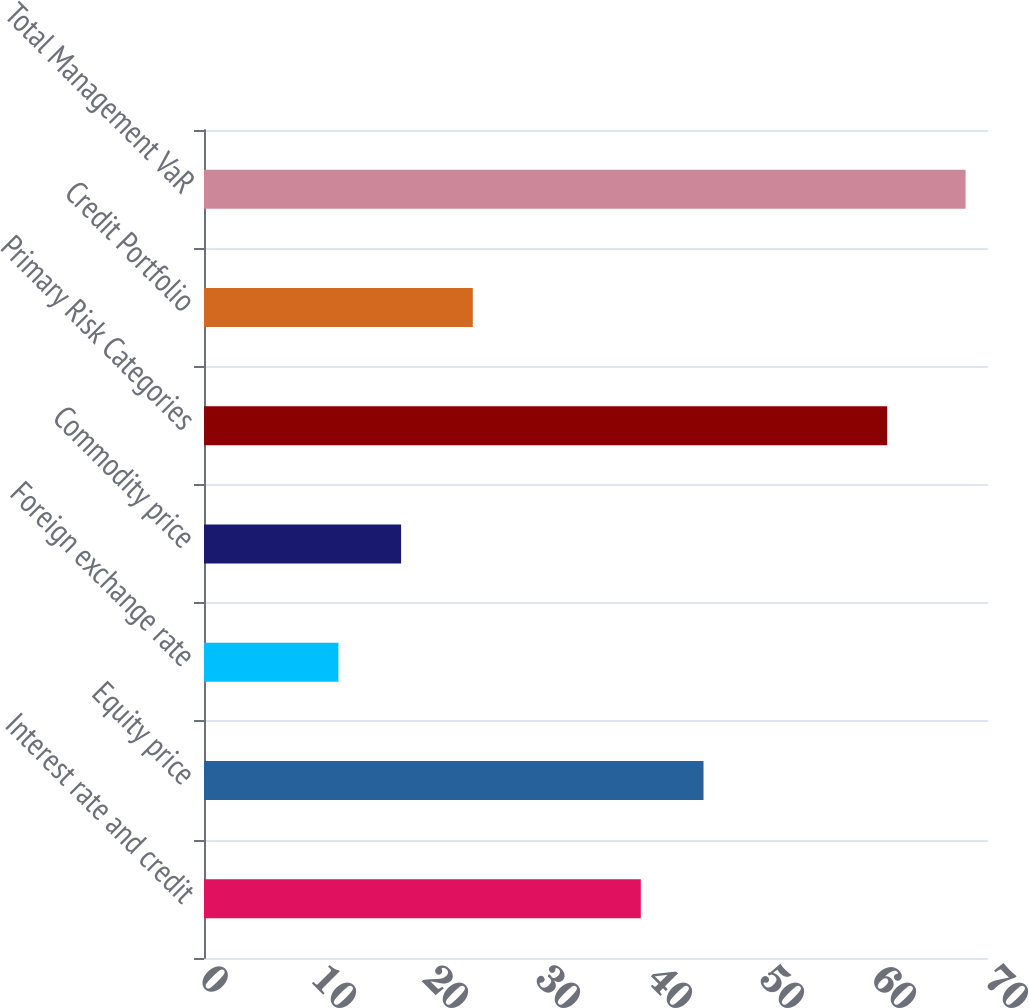<chart> <loc_0><loc_0><loc_500><loc_500><bar_chart><fcel>Interest rate and credit<fcel>Equity price<fcel>Foreign exchange rate<fcel>Commodity price<fcel>Primary Risk Categories<fcel>Credit Portfolio<fcel>Total Management VaR<nl><fcel>39<fcel>44.6<fcel>12<fcel>17.6<fcel>61<fcel>24<fcel>68<nl></chart> 